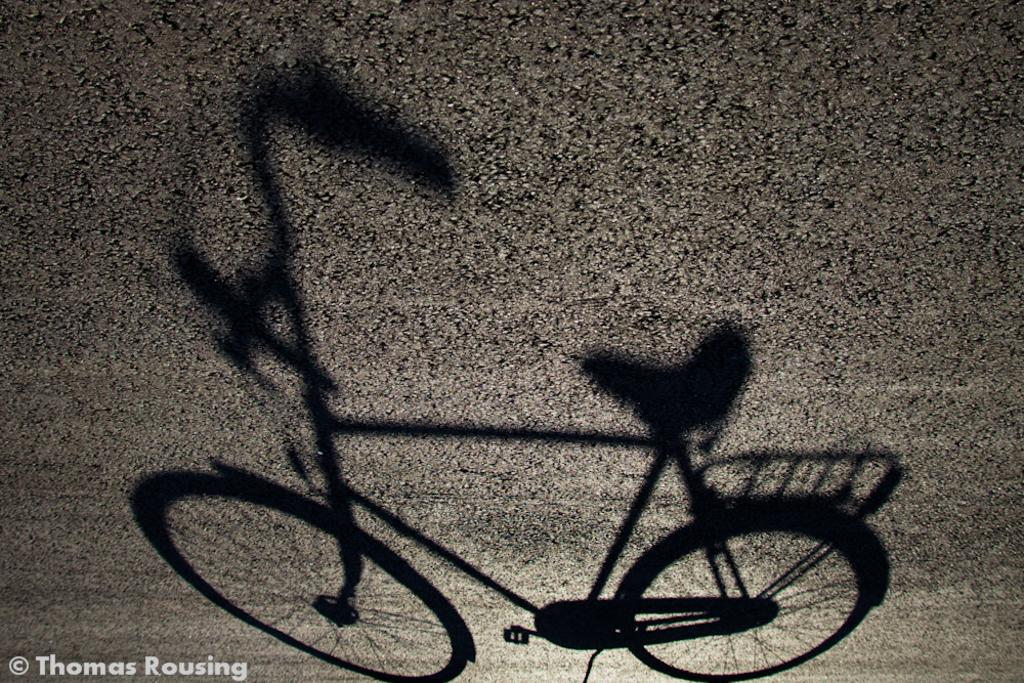What is the main subject of the image? There is a bicycle in the image. Can you describe the background of the image? The background of the image is blurry. Is there any additional information or branding present in the image? Yes, there is a watermark in the bottom left of the image. What type of robin can be seen sitting on the handlebars of the bicycle in the image? There is no robin present in the image; it only features a bicycle and a blurry background. What books are visible on the bicycle in the image? There are no books visible in the image; it only features a bicycle and a blurry background. 